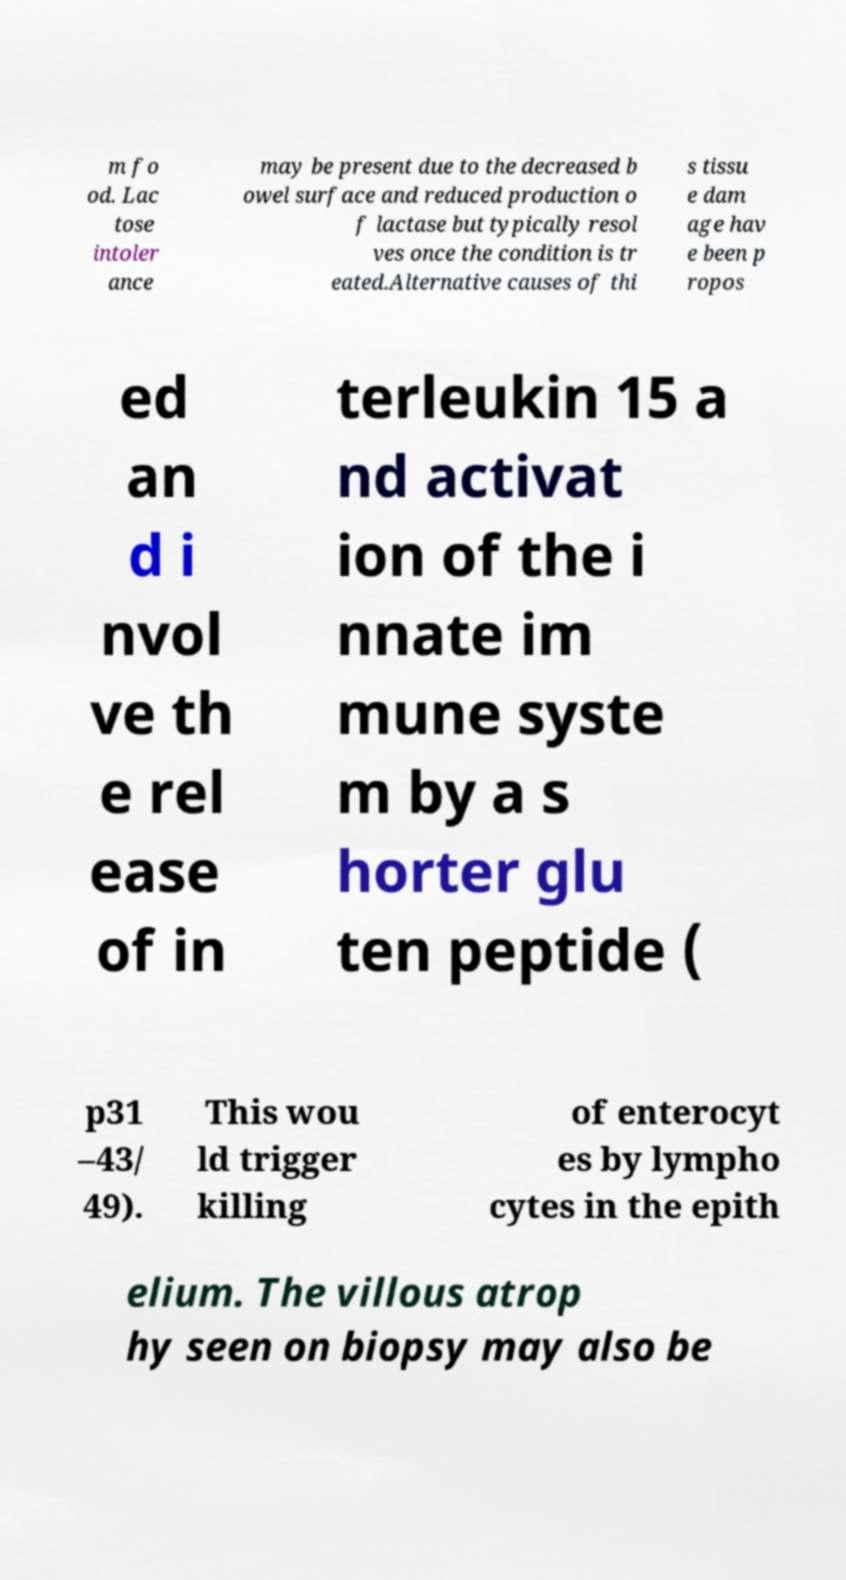Can you read and provide the text displayed in the image?This photo seems to have some interesting text. Can you extract and type it out for me? m fo od. Lac tose intoler ance may be present due to the decreased b owel surface and reduced production o f lactase but typically resol ves once the condition is tr eated.Alternative causes of thi s tissu e dam age hav e been p ropos ed an d i nvol ve th e rel ease of in terleukin 15 a nd activat ion of the i nnate im mune syste m by a s horter glu ten peptide ( p31 –43/ 49). This wou ld trigger killing of enterocyt es by lympho cytes in the epith elium. The villous atrop hy seen on biopsy may also be 